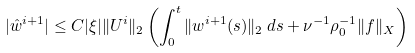<formula> <loc_0><loc_0><loc_500><loc_500>| \hat { w } ^ { i + 1 } | \leq C | \xi | \| U ^ { i } \| _ { 2 } \left ( \int _ { 0 } ^ { t } \| w ^ { i + 1 } ( s ) \| _ { 2 } \, d s + \nu ^ { - 1 } \rho _ { 0 } ^ { - 1 } \| f \| _ { X } \right )</formula> 